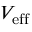Convert formula to latex. <formula><loc_0><loc_0><loc_500><loc_500>V _ { e f f }</formula> 